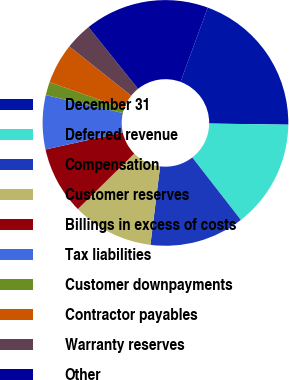Convert chart. <chart><loc_0><loc_0><loc_500><loc_500><pie_chart><fcel>December 31<fcel>Deferred revenue<fcel>Compensation<fcel>Customer reserves<fcel>Billings in excess of costs<fcel>Tax liabilities<fcel>Customer downpayments<fcel>Contractor payables<fcel>Warranty reserves<fcel>Other<nl><fcel>19.63%<fcel>14.26%<fcel>12.47%<fcel>10.68%<fcel>8.9%<fcel>7.11%<fcel>1.74%<fcel>5.32%<fcel>3.53%<fcel>16.37%<nl></chart> 